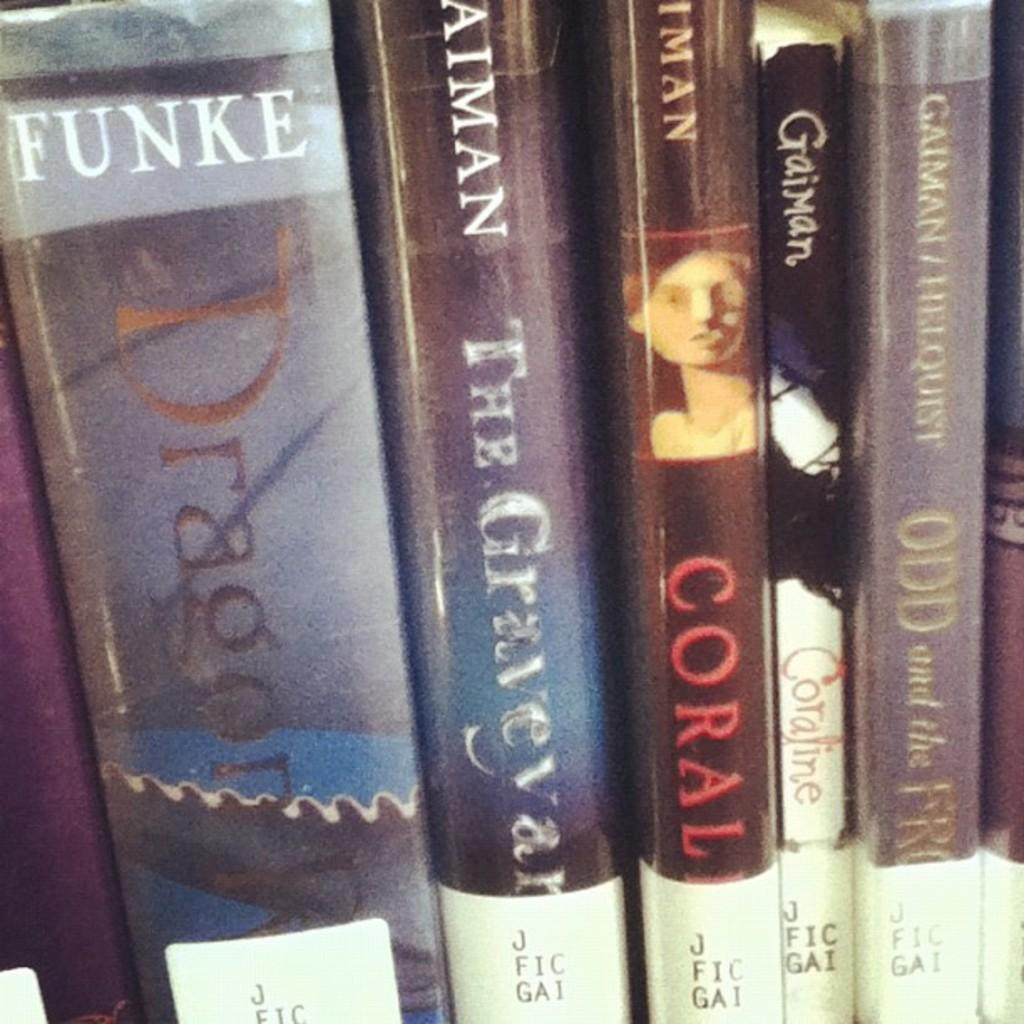<image>
Present a compact description of the photo's key features. A book by Coral sits among a book by Funke 